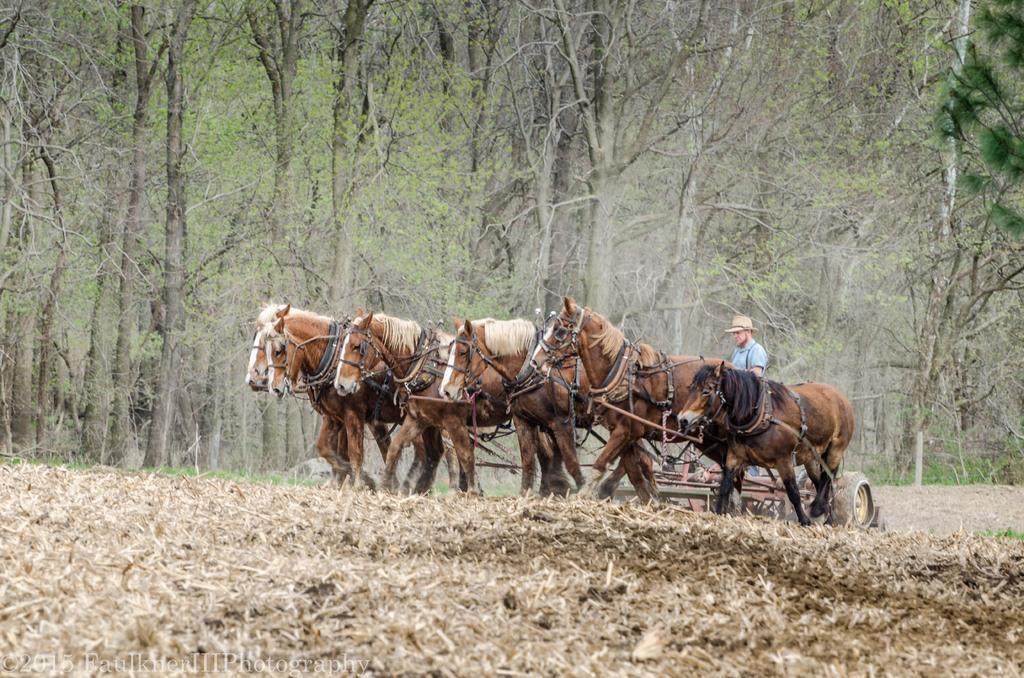Please provide a concise description of this image. In this image I can see many horses which are in brown and black color. I can see one person with blue color dress and hat. The person is standing on the cart. In the background there are many trees. 